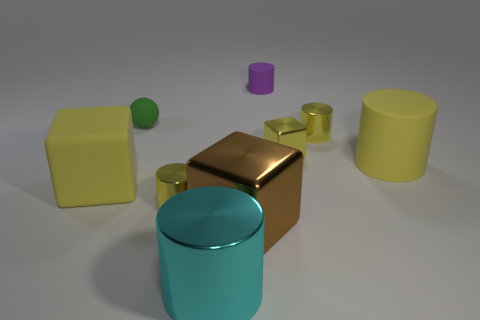What number of matte things are yellow balls or small yellow cylinders?
Your answer should be compact. 0. There is a yellow rubber object that is left of the tiny purple rubber thing; is its shape the same as the large yellow object that is to the right of the big brown thing?
Provide a short and direct response. No. Is there another purple cylinder made of the same material as the purple cylinder?
Offer a very short reply. No. What is the color of the ball?
Your response must be concise. Green. There is a yellow metallic cylinder that is to the right of the tiny block; what is its size?
Give a very brief answer. Small. What number of large metal cylinders are the same color as the tiny metal block?
Your response must be concise. 0. Is there a small purple matte cylinder that is in front of the big object that is behind the rubber cube?
Provide a succinct answer. No. There is a shiny thing that is behind the small yellow metallic cube; is it the same color as the large cylinder that is behind the large cyan thing?
Your answer should be compact. Yes. What color is the matte thing that is the same size as the yellow rubber cylinder?
Provide a short and direct response. Yellow. Are there the same number of big brown metallic objects in front of the big brown block and tiny balls that are to the left of the tiny purple rubber object?
Offer a very short reply. No. 